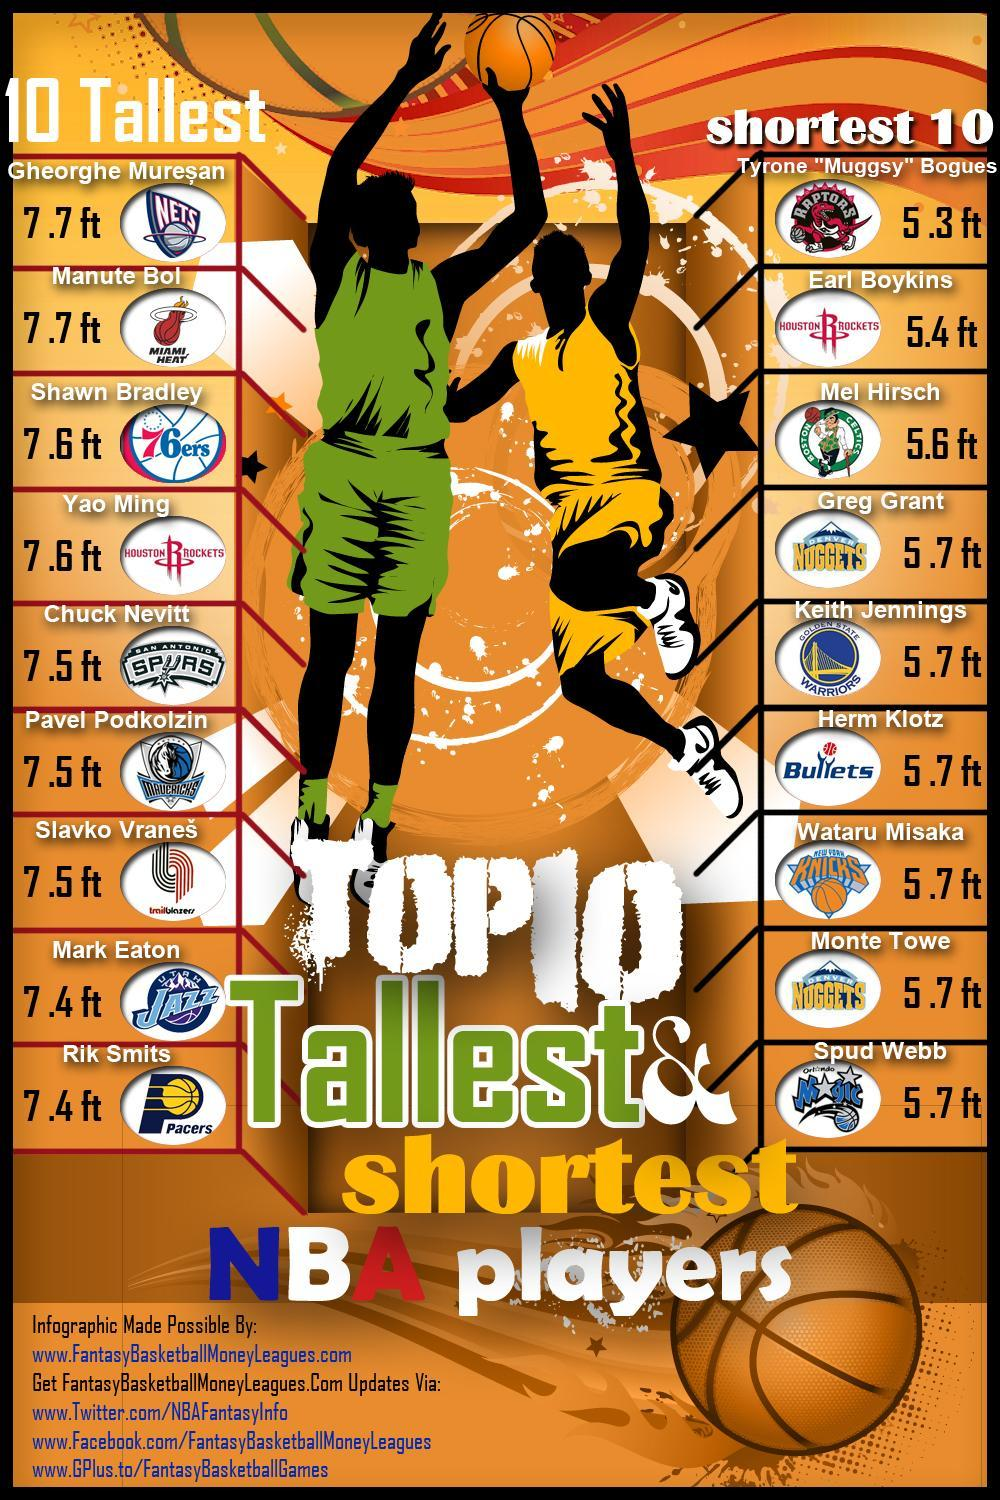Who all are from Houston Rockets
Answer the question with a short phrase. Yao Ming, Earl Boykins Which is the most common height in the shortest 10 5.7 ft Who all have a height of 7.5 ft Check Nevitt, Pavel Podkolzin, Slavko Vranes Earl Boykins belongs to which team Houston Rockets Shawn Bradley belongs to which team 76ers Who is from trailblazers slavko vranes Greg Grant is form which team Denver Nuggets 